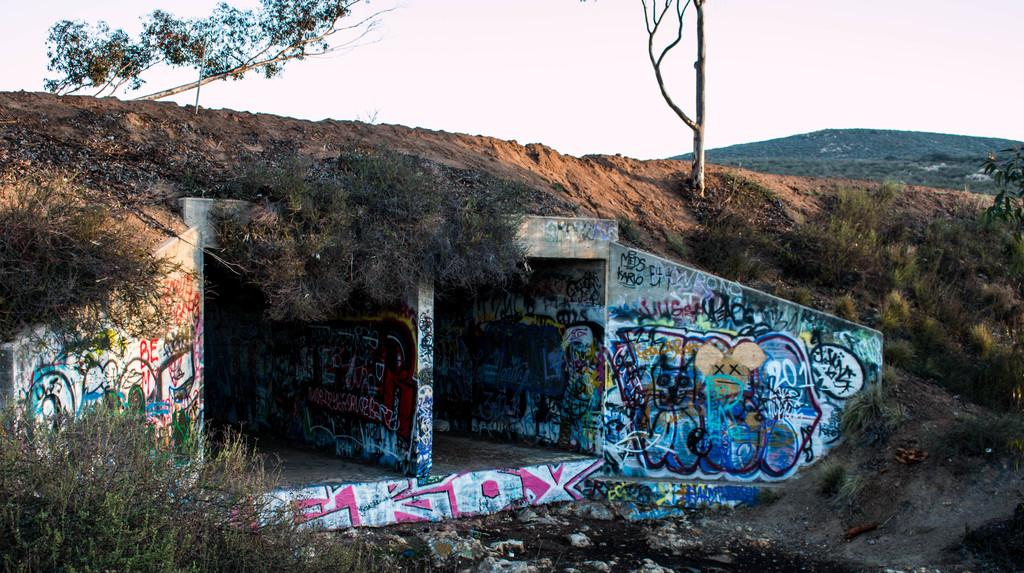<image>
Provide a brief description of the given image. An old tunnel is painted with Graffitu with the numbers 201 